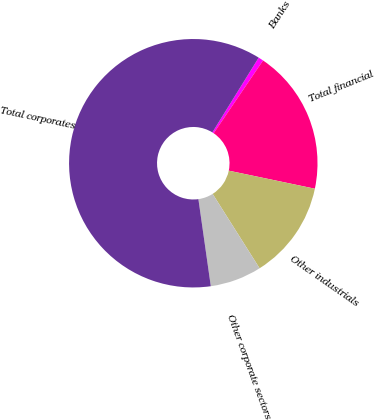Convert chart to OTSL. <chart><loc_0><loc_0><loc_500><loc_500><pie_chart><fcel>Banks<fcel>Total financial<fcel>Other industrials<fcel>Other corporate sectors<fcel>Total corporates<nl><fcel>0.67%<fcel>18.79%<fcel>12.75%<fcel>6.71%<fcel>61.07%<nl></chart> 